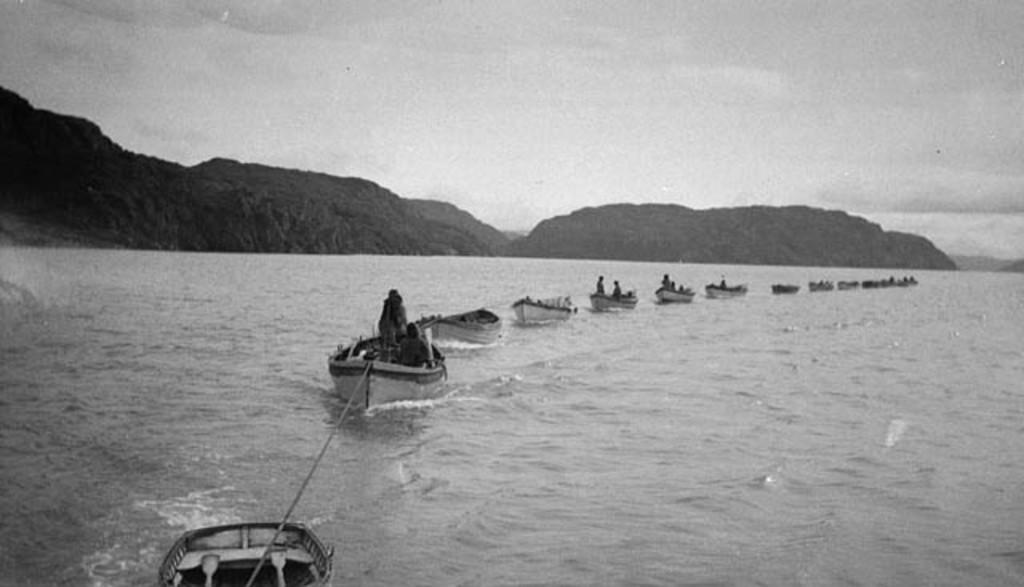What is the color scheme of the image? The image is black and white. What are the people in the image doing? The people are in boats in the image. What is the boats' movement on the water? The boats are moving on the water. What type of landscape can be seen in the image? There are hills visible in the image. What part of the natural environment is visible in the image? The sky is visible in the image. What type of butter can be seen in the image? There is no butter present in the image. 